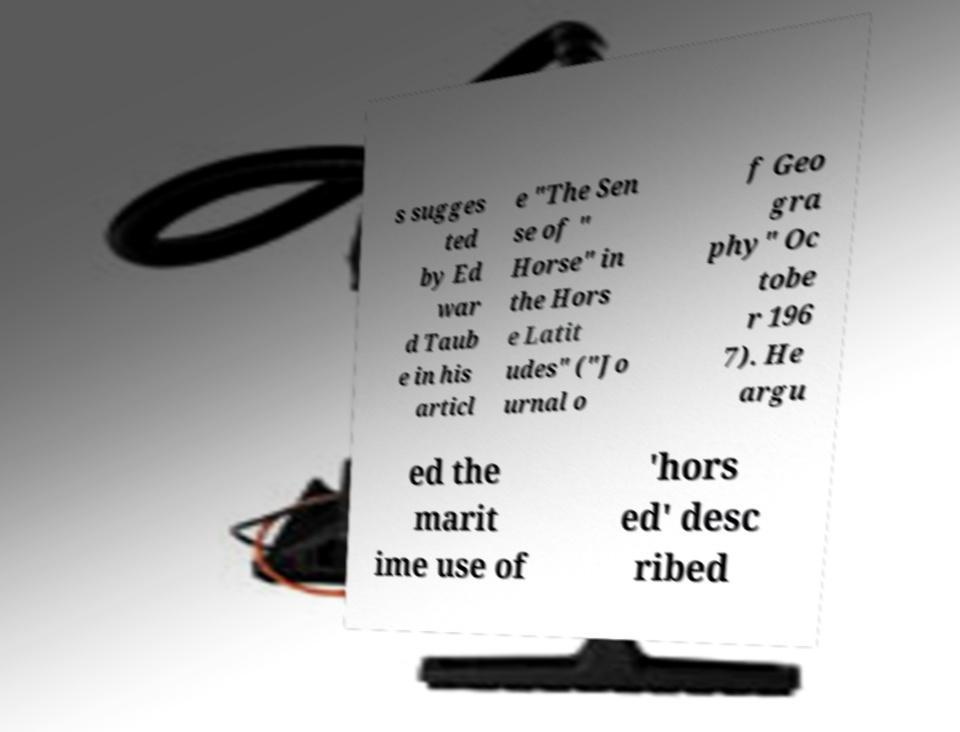What messages or text are displayed in this image? I need them in a readable, typed format. s sugges ted by Ed war d Taub e in his articl e "The Sen se of " Horse" in the Hors e Latit udes" ("Jo urnal o f Geo gra phy" Oc tobe r 196 7). He argu ed the marit ime use of 'hors ed' desc ribed 